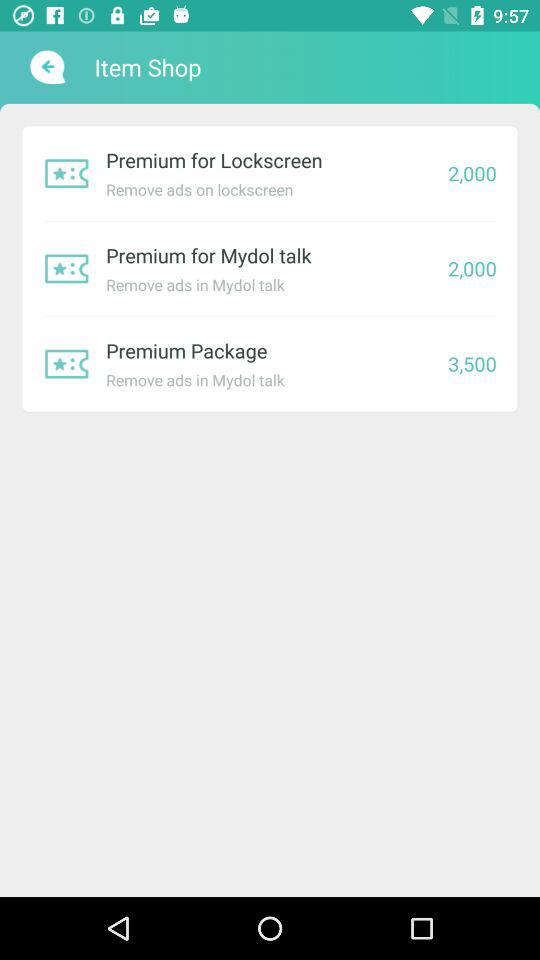How much more expensive is Premium Package than Premium for Lockscreen?
Answer the question using a single word or phrase. 1500 